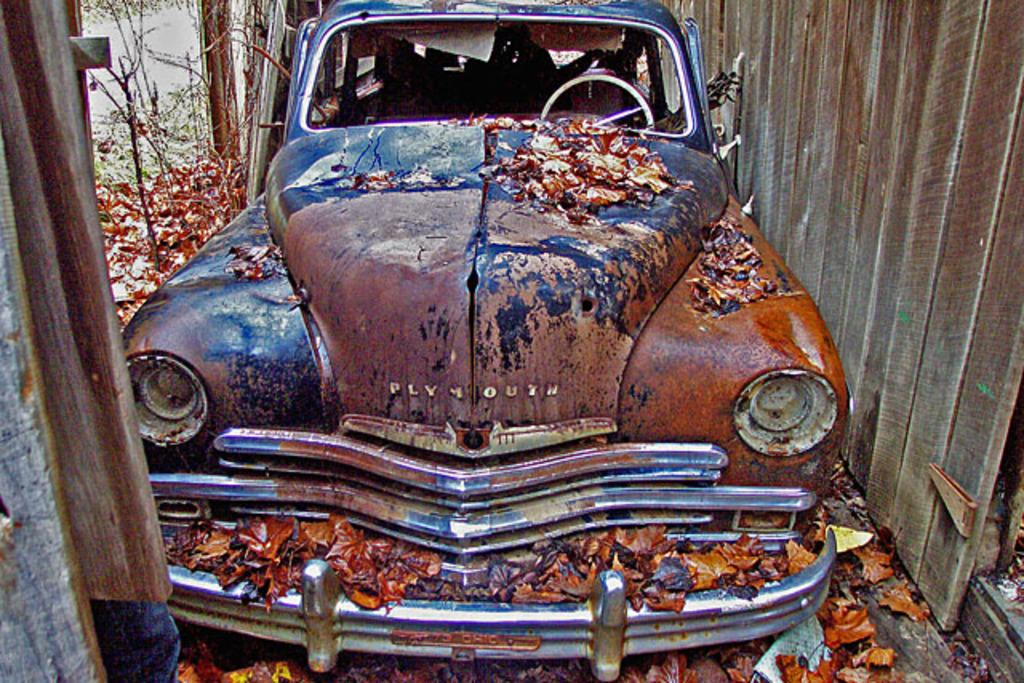What is on the ground in the image? There is a car on the ground in the image. What can be seen in the background of the image? There is a wooden shed, plants, and trees visible in the background of the image. Can you describe the time of day when the image was taken? The image was taken during the day. What type of tooth is visible in the image? There is no tooth present in the image. Who is the manager in the image? There is no manager or any people present in the image. 